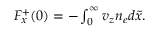Convert formula to latex. <formula><loc_0><loc_0><loc_500><loc_500>\begin{array} { r } { F _ { x } ^ { + } ( 0 ) = - \int _ { 0 } ^ { \infty } v _ { z } n _ { e } d \tilde { x } . } \end{array}</formula> 